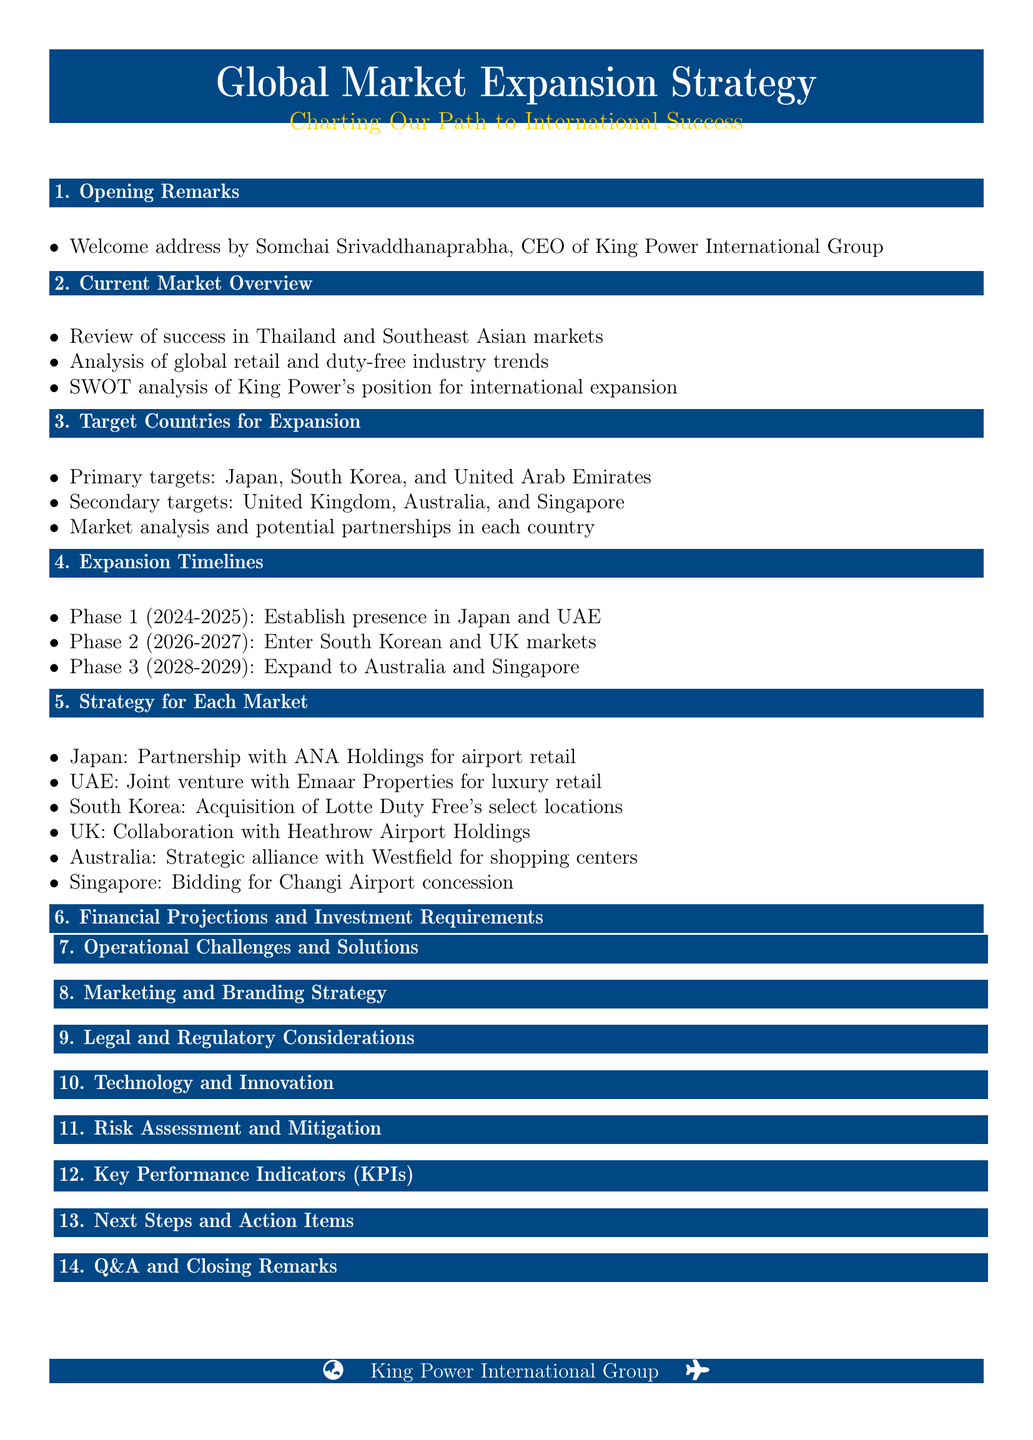What are the primary target countries for expansion? The primary target countries for expansion are listed in the agenda under the "Target Countries for Expansion" section.
Answer: Japan, South Korea, United Arab Emirates What phase will the company establish a presence in Japan? The expansion timelines specify the phases for entering each target country.
Answer: Phase 1 (2024-2025) Which company is partnering with King Power in Japan? The "Strategy for Each Market" section details specific partnerships for each country.
Answer: ANA Holdings What is one of the operational challenges mentioned? The document lists operational challenges in the "Operational Challenges and Solutions" section, emphasizing key difficulties faced in expansion.
Answer: Supply chain management What year does Phase 2 of the expansion start? The "Expansion Timelines" section provides the timeline for each phase of the expansion plan.
Answer: 2026 What is the focus of the legal considerations in the meeting? The agenda outlines legal considerations that the company intends to focus on in international markets.
Answer: Duty-free regulations What is a key performance indicator for the expansion? The "Key Performance Indicators (KPIs)" section identifies specific metrics to measure success in new markets.
Answer: Market share in new countries How many target countries are listed as secondary targets? The "Target Countries for Expansion" section specifies the number of primary and secondary target countries overall.
Answer: Three 